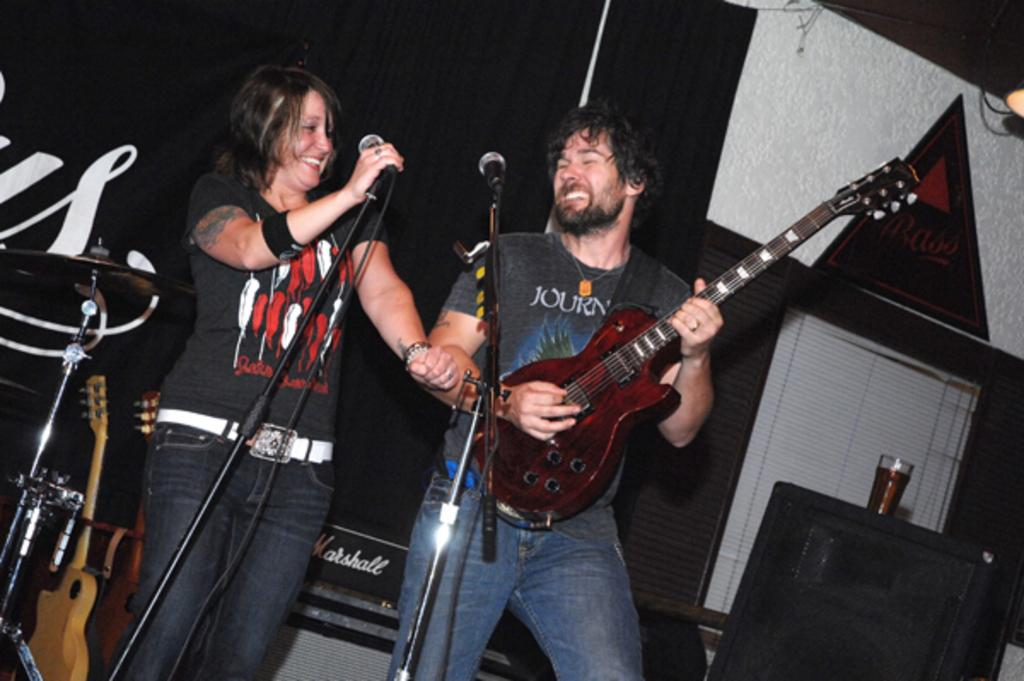How many people are in the image? There are two people in the image. What are the people doing in the image? Both people are standing in front of a mic. What instrument is one of the people holding? One person is holding a guitar. What type of creature is causing trouble for the people in the image? There is no creature present in the image, nor is there any indication of trouble. 